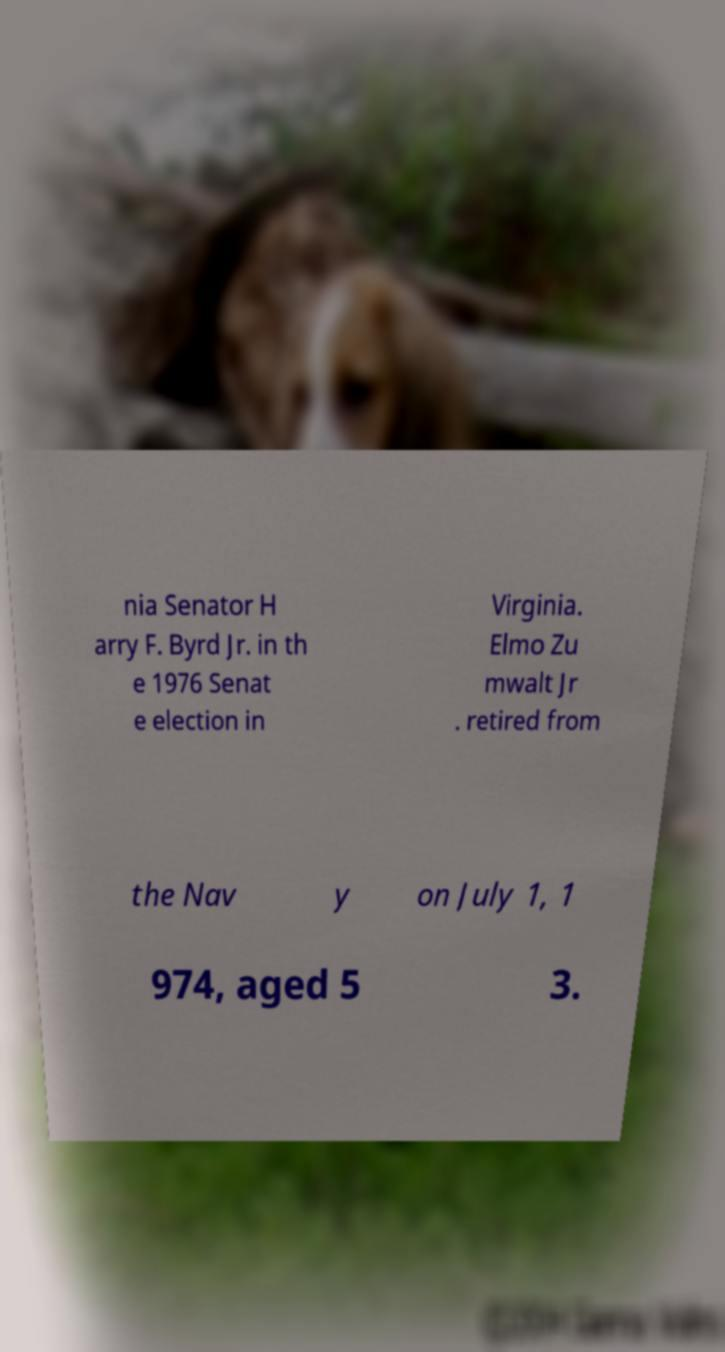What messages or text are displayed in this image? I need them in a readable, typed format. nia Senator H arry F. Byrd Jr. in th e 1976 Senat e election in Virginia. Elmo Zu mwalt Jr . retired from the Nav y on July 1, 1 974, aged 5 3. 